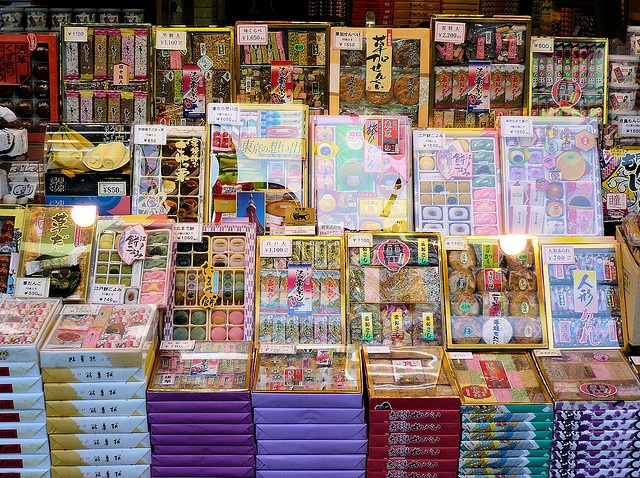Describe the objects in this image and their specific colors. I can see banana in black, olive, orange, and tan tones, donut in black, lavender, darkgray, and gray tones, donut in black, brown, maroon, and gray tones, donut in black, darkgray, gray, and tan tones, and donut in black, darkgray, tan, gray, and olive tones in this image. 